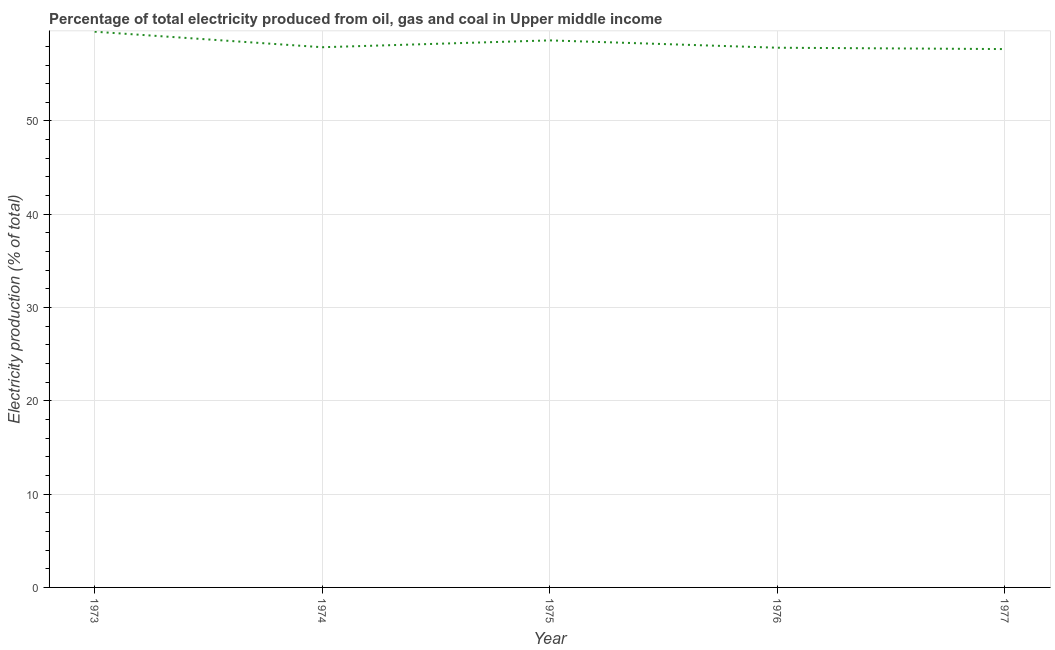What is the electricity production in 1975?
Offer a terse response. 58.64. Across all years, what is the maximum electricity production?
Ensure brevity in your answer.  59.57. Across all years, what is the minimum electricity production?
Offer a very short reply. 57.71. In which year was the electricity production minimum?
Make the answer very short. 1977. What is the sum of the electricity production?
Your response must be concise. 291.69. What is the difference between the electricity production in 1973 and 1977?
Offer a very short reply. 1.86. What is the average electricity production per year?
Offer a very short reply. 58.34. What is the median electricity production?
Give a very brief answer. 57.91. What is the ratio of the electricity production in 1973 to that in 1976?
Your answer should be very brief. 1.03. What is the difference between the highest and the second highest electricity production?
Keep it short and to the point. 0.93. What is the difference between the highest and the lowest electricity production?
Provide a short and direct response. 1.86. In how many years, is the electricity production greater than the average electricity production taken over all years?
Offer a very short reply. 2. Does the electricity production monotonically increase over the years?
Ensure brevity in your answer.  No. How many years are there in the graph?
Provide a short and direct response. 5. What is the difference between two consecutive major ticks on the Y-axis?
Keep it short and to the point. 10. Does the graph contain any zero values?
Provide a succinct answer. No. Does the graph contain grids?
Provide a short and direct response. Yes. What is the title of the graph?
Keep it short and to the point. Percentage of total electricity produced from oil, gas and coal in Upper middle income. What is the label or title of the Y-axis?
Ensure brevity in your answer.  Electricity production (% of total). What is the Electricity production (% of total) in 1973?
Ensure brevity in your answer.  59.57. What is the Electricity production (% of total) of 1974?
Offer a very short reply. 57.91. What is the Electricity production (% of total) of 1975?
Ensure brevity in your answer.  58.64. What is the Electricity production (% of total) of 1976?
Your response must be concise. 57.85. What is the Electricity production (% of total) in 1977?
Offer a very short reply. 57.71. What is the difference between the Electricity production (% of total) in 1973 and 1974?
Ensure brevity in your answer.  1.67. What is the difference between the Electricity production (% of total) in 1973 and 1975?
Offer a very short reply. 0.93. What is the difference between the Electricity production (% of total) in 1973 and 1976?
Offer a terse response. 1.72. What is the difference between the Electricity production (% of total) in 1973 and 1977?
Your answer should be compact. 1.86. What is the difference between the Electricity production (% of total) in 1974 and 1975?
Your answer should be compact. -0.73. What is the difference between the Electricity production (% of total) in 1974 and 1976?
Make the answer very short. 0.05. What is the difference between the Electricity production (% of total) in 1974 and 1977?
Provide a succinct answer. 0.2. What is the difference between the Electricity production (% of total) in 1975 and 1976?
Make the answer very short. 0.79. What is the difference between the Electricity production (% of total) in 1975 and 1977?
Keep it short and to the point. 0.93. What is the difference between the Electricity production (% of total) in 1976 and 1977?
Your answer should be very brief. 0.14. What is the ratio of the Electricity production (% of total) in 1973 to that in 1974?
Your answer should be very brief. 1.03. What is the ratio of the Electricity production (% of total) in 1973 to that in 1977?
Provide a short and direct response. 1.03. What is the ratio of the Electricity production (% of total) in 1974 to that in 1976?
Your answer should be compact. 1. What is the ratio of the Electricity production (% of total) in 1975 to that in 1977?
Ensure brevity in your answer.  1.02. What is the ratio of the Electricity production (% of total) in 1976 to that in 1977?
Your response must be concise. 1. 